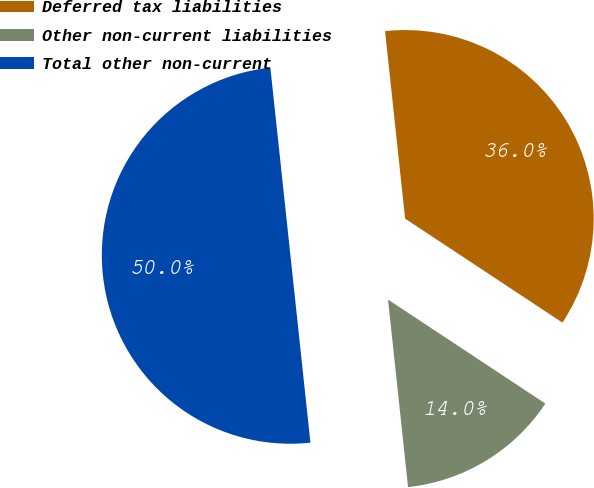Convert chart to OTSL. <chart><loc_0><loc_0><loc_500><loc_500><pie_chart><fcel>Deferred tax liabilities<fcel>Other non-current liabilities<fcel>Total other non-current<nl><fcel>35.99%<fcel>14.01%<fcel>50.0%<nl></chart> 